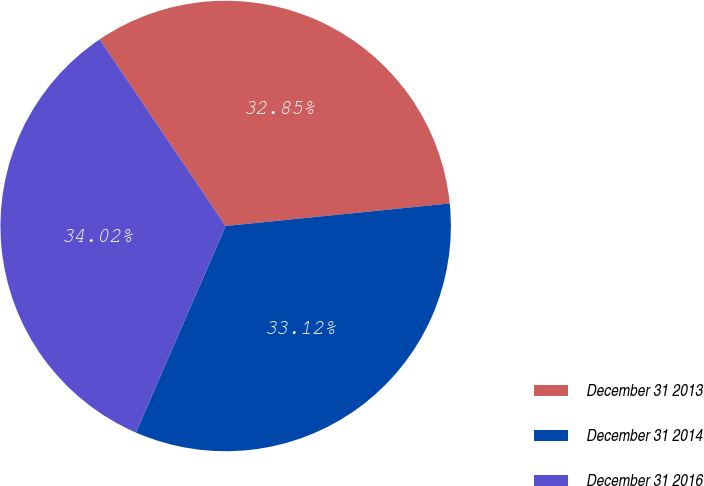Convert chart to OTSL. <chart><loc_0><loc_0><loc_500><loc_500><pie_chart><fcel>December 31 2013<fcel>December 31 2014<fcel>December 31 2016<nl><fcel>32.85%<fcel>33.12%<fcel>34.02%<nl></chart> 